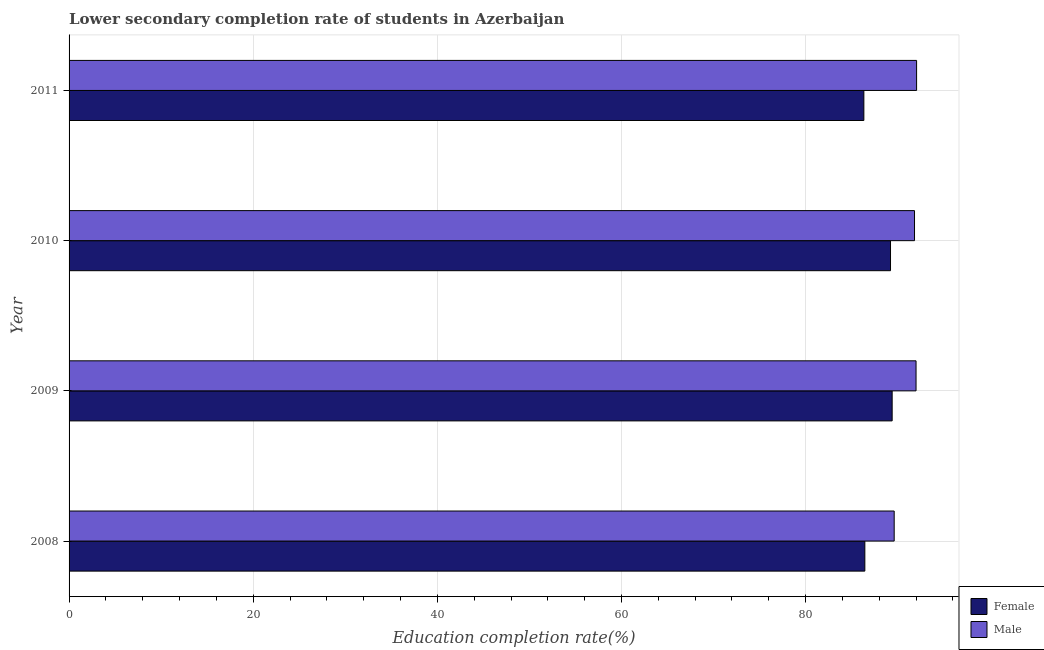Are the number of bars per tick equal to the number of legend labels?
Give a very brief answer. Yes. Are the number of bars on each tick of the Y-axis equal?
Provide a short and direct response. Yes. How many bars are there on the 4th tick from the bottom?
Offer a very short reply. 2. In how many cases, is the number of bars for a given year not equal to the number of legend labels?
Offer a very short reply. 0. What is the education completion rate of male students in 2011?
Your response must be concise. 92.05. Across all years, what is the maximum education completion rate of male students?
Keep it short and to the point. 92.05. Across all years, what is the minimum education completion rate of female students?
Provide a short and direct response. 86.32. What is the total education completion rate of male students in the graph?
Keep it short and to the point. 365.49. What is the difference between the education completion rate of male students in 2009 and that in 2011?
Your answer should be very brief. -0.06. What is the difference between the education completion rate of male students in 2009 and the education completion rate of female students in 2011?
Offer a terse response. 5.67. What is the average education completion rate of male students per year?
Provide a short and direct response. 91.37. In the year 2009, what is the difference between the education completion rate of male students and education completion rate of female students?
Provide a succinct answer. 2.6. Is the education completion rate of female students in 2008 less than that in 2010?
Your answer should be compact. Yes. Is the difference between the education completion rate of female students in 2008 and 2011 greater than the difference between the education completion rate of male students in 2008 and 2011?
Offer a terse response. Yes. What is the difference between the highest and the second highest education completion rate of female students?
Your answer should be very brief. 0.18. What is the difference between the highest and the lowest education completion rate of female students?
Provide a short and direct response. 3.07. Is the sum of the education completion rate of female students in 2008 and 2011 greater than the maximum education completion rate of male students across all years?
Offer a very short reply. Yes. What does the 1st bar from the top in 2010 represents?
Provide a succinct answer. Male. What does the 1st bar from the bottom in 2011 represents?
Make the answer very short. Female. How many bars are there?
Your response must be concise. 8. What is the difference between two consecutive major ticks on the X-axis?
Your answer should be compact. 20. Does the graph contain any zero values?
Provide a succinct answer. No. Does the graph contain grids?
Make the answer very short. Yes. Where does the legend appear in the graph?
Make the answer very short. Bottom right. What is the title of the graph?
Ensure brevity in your answer.  Lower secondary completion rate of students in Azerbaijan. What is the label or title of the X-axis?
Your answer should be very brief. Education completion rate(%). What is the Education completion rate(%) in Female in 2008?
Your answer should be compact. 86.43. What is the Education completion rate(%) in Male in 2008?
Your answer should be compact. 89.62. What is the Education completion rate(%) of Female in 2009?
Give a very brief answer. 89.4. What is the Education completion rate(%) of Male in 2009?
Provide a succinct answer. 91.99. What is the Education completion rate(%) of Female in 2010?
Your answer should be compact. 89.22. What is the Education completion rate(%) of Male in 2010?
Your answer should be compact. 91.83. What is the Education completion rate(%) in Female in 2011?
Your response must be concise. 86.32. What is the Education completion rate(%) in Male in 2011?
Your answer should be compact. 92.05. Across all years, what is the maximum Education completion rate(%) in Female?
Offer a terse response. 89.4. Across all years, what is the maximum Education completion rate(%) in Male?
Make the answer very short. 92.05. Across all years, what is the minimum Education completion rate(%) of Female?
Your answer should be very brief. 86.32. Across all years, what is the minimum Education completion rate(%) of Male?
Offer a very short reply. 89.62. What is the total Education completion rate(%) of Female in the graph?
Your answer should be compact. 351.37. What is the total Education completion rate(%) in Male in the graph?
Offer a very short reply. 365.49. What is the difference between the Education completion rate(%) in Female in 2008 and that in 2009?
Make the answer very short. -2.97. What is the difference between the Education completion rate(%) of Male in 2008 and that in 2009?
Keep it short and to the point. -2.37. What is the difference between the Education completion rate(%) of Female in 2008 and that in 2010?
Your answer should be compact. -2.79. What is the difference between the Education completion rate(%) of Male in 2008 and that in 2010?
Your answer should be compact. -2.21. What is the difference between the Education completion rate(%) of Female in 2008 and that in 2011?
Give a very brief answer. 0.11. What is the difference between the Education completion rate(%) of Male in 2008 and that in 2011?
Give a very brief answer. -2.43. What is the difference between the Education completion rate(%) of Female in 2009 and that in 2010?
Your response must be concise. 0.18. What is the difference between the Education completion rate(%) in Male in 2009 and that in 2010?
Offer a very short reply. 0.17. What is the difference between the Education completion rate(%) of Female in 2009 and that in 2011?
Provide a short and direct response. 3.07. What is the difference between the Education completion rate(%) in Male in 2009 and that in 2011?
Your answer should be very brief. -0.06. What is the difference between the Education completion rate(%) in Female in 2010 and that in 2011?
Make the answer very short. 2.9. What is the difference between the Education completion rate(%) of Male in 2010 and that in 2011?
Make the answer very short. -0.23. What is the difference between the Education completion rate(%) of Female in 2008 and the Education completion rate(%) of Male in 2009?
Give a very brief answer. -5.56. What is the difference between the Education completion rate(%) in Female in 2008 and the Education completion rate(%) in Male in 2010?
Offer a very short reply. -5.4. What is the difference between the Education completion rate(%) of Female in 2008 and the Education completion rate(%) of Male in 2011?
Your response must be concise. -5.62. What is the difference between the Education completion rate(%) of Female in 2009 and the Education completion rate(%) of Male in 2010?
Offer a very short reply. -2.43. What is the difference between the Education completion rate(%) of Female in 2009 and the Education completion rate(%) of Male in 2011?
Provide a short and direct response. -2.65. What is the difference between the Education completion rate(%) of Female in 2010 and the Education completion rate(%) of Male in 2011?
Your answer should be compact. -2.83. What is the average Education completion rate(%) of Female per year?
Ensure brevity in your answer.  87.84. What is the average Education completion rate(%) in Male per year?
Your answer should be compact. 91.37. In the year 2008, what is the difference between the Education completion rate(%) in Female and Education completion rate(%) in Male?
Ensure brevity in your answer.  -3.19. In the year 2009, what is the difference between the Education completion rate(%) of Female and Education completion rate(%) of Male?
Provide a short and direct response. -2.6. In the year 2010, what is the difference between the Education completion rate(%) in Female and Education completion rate(%) in Male?
Offer a very short reply. -2.61. In the year 2011, what is the difference between the Education completion rate(%) in Female and Education completion rate(%) in Male?
Give a very brief answer. -5.73. What is the ratio of the Education completion rate(%) of Female in 2008 to that in 2009?
Offer a terse response. 0.97. What is the ratio of the Education completion rate(%) of Male in 2008 to that in 2009?
Give a very brief answer. 0.97. What is the ratio of the Education completion rate(%) of Female in 2008 to that in 2010?
Offer a very short reply. 0.97. What is the ratio of the Education completion rate(%) of Male in 2008 to that in 2011?
Keep it short and to the point. 0.97. What is the ratio of the Education completion rate(%) in Female in 2009 to that in 2011?
Ensure brevity in your answer.  1.04. What is the ratio of the Education completion rate(%) in Female in 2010 to that in 2011?
Offer a very short reply. 1.03. What is the ratio of the Education completion rate(%) in Male in 2010 to that in 2011?
Keep it short and to the point. 1. What is the difference between the highest and the second highest Education completion rate(%) of Female?
Make the answer very short. 0.18. What is the difference between the highest and the second highest Education completion rate(%) of Male?
Provide a short and direct response. 0.06. What is the difference between the highest and the lowest Education completion rate(%) of Female?
Give a very brief answer. 3.07. What is the difference between the highest and the lowest Education completion rate(%) of Male?
Your answer should be very brief. 2.43. 